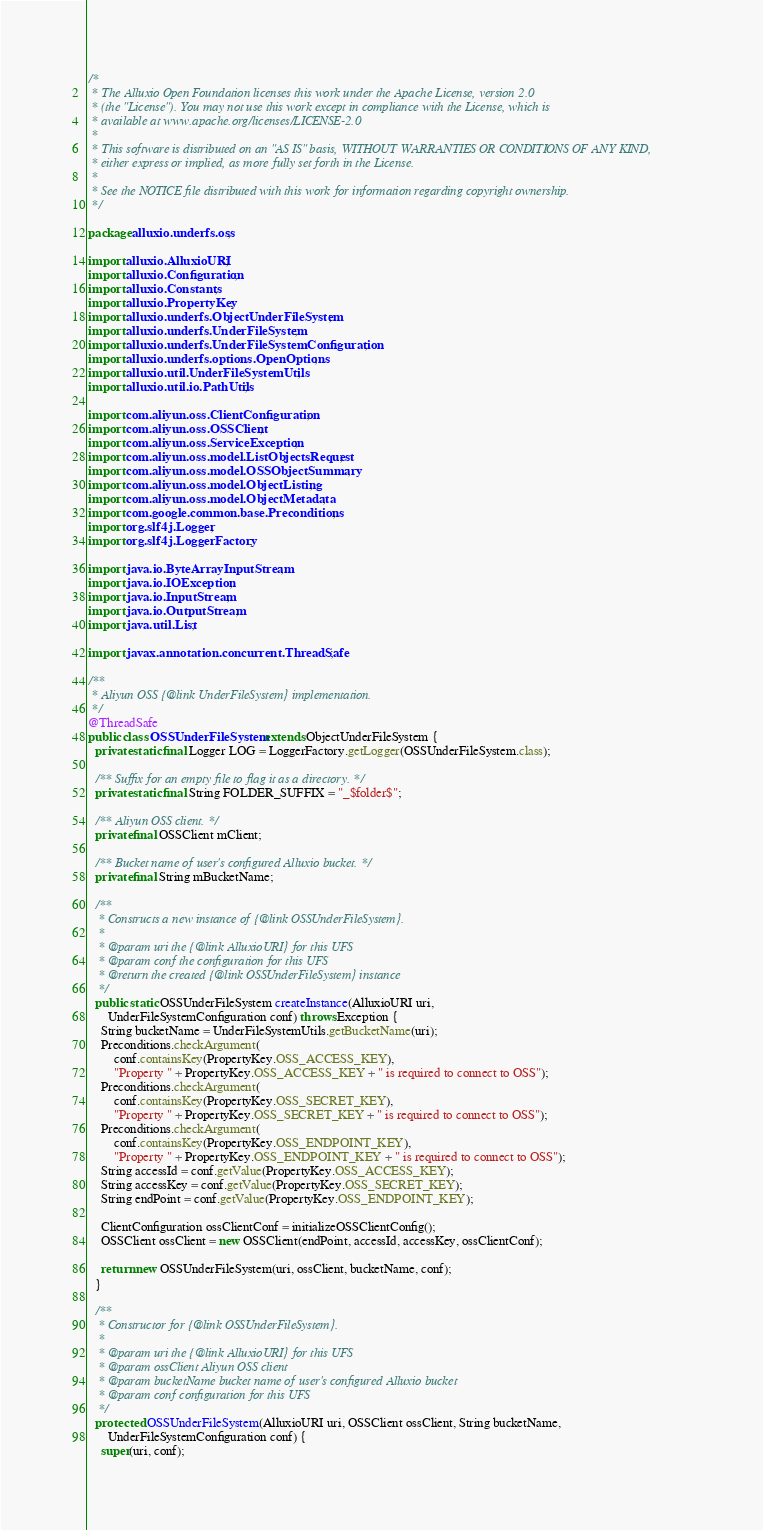<code> <loc_0><loc_0><loc_500><loc_500><_Java_>/*
 * The Alluxio Open Foundation licenses this work under the Apache License, version 2.0
 * (the "License"). You may not use this work except in compliance with the License, which is
 * available at www.apache.org/licenses/LICENSE-2.0
 *
 * This software is distributed on an "AS IS" basis, WITHOUT WARRANTIES OR CONDITIONS OF ANY KIND,
 * either express or implied, as more fully set forth in the License.
 *
 * See the NOTICE file distributed with this work for information regarding copyright ownership.
 */

package alluxio.underfs.oss;

import alluxio.AlluxioURI;
import alluxio.Configuration;
import alluxio.Constants;
import alluxio.PropertyKey;
import alluxio.underfs.ObjectUnderFileSystem;
import alluxio.underfs.UnderFileSystem;
import alluxio.underfs.UnderFileSystemConfiguration;
import alluxio.underfs.options.OpenOptions;
import alluxio.util.UnderFileSystemUtils;
import alluxio.util.io.PathUtils;

import com.aliyun.oss.ClientConfiguration;
import com.aliyun.oss.OSSClient;
import com.aliyun.oss.ServiceException;
import com.aliyun.oss.model.ListObjectsRequest;
import com.aliyun.oss.model.OSSObjectSummary;
import com.aliyun.oss.model.ObjectListing;
import com.aliyun.oss.model.ObjectMetadata;
import com.google.common.base.Preconditions;
import org.slf4j.Logger;
import org.slf4j.LoggerFactory;

import java.io.ByteArrayInputStream;
import java.io.IOException;
import java.io.InputStream;
import java.io.OutputStream;
import java.util.List;

import javax.annotation.concurrent.ThreadSafe;

/**
 * Aliyun OSS {@link UnderFileSystem} implementation.
 */
@ThreadSafe
public class OSSUnderFileSystem extends ObjectUnderFileSystem {
  private static final Logger LOG = LoggerFactory.getLogger(OSSUnderFileSystem.class);

  /** Suffix for an empty file to flag it as a directory. */
  private static final String FOLDER_SUFFIX = "_$folder$";

  /** Aliyun OSS client. */
  private final OSSClient mClient;

  /** Bucket name of user's configured Alluxio bucket. */
  private final String mBucketName;

  /**
   * Constructs a new instance of {@link OSSUnderFileSystem}.
   *
   * @param uri the {@link AlluxioURI} for this UFS
   * @param conf the configuration for this UFS
   * @return the created {@link OSSUnderFileSystem} instance
   */
  public static OSSUnderFileSystem createInstance(AlluxioURI uri,
      UnderFileSystemConfiguration conf) throws Exception {
    String bucketName = UnderFileSystemUtils.getBucketName(uri);
    Preconditions.checkArgument(
        conf.containsKey(PropertyKey.OSS_ACCESS_KEY),
        "Property " + PropertyKey.OSS_ACCESS_KEY + " is required to connect to OSS");
    Preconditions.checkArgument(
        conf.containsKey(PropertyKey.OSS_SECRET_KEY),
        "Property " + PropertyKey.OSS_SECRET_KEY + " is required to connect to OSS");
    Preconditions.checkArgument(
        conf.containsKey(PropertyKey.OSS_ENDPOINT_KEY),
        "Property " + PropertyKey.OSS_ENDPOINT_KEY + " is required to connect to OSS");
    String accessId = conf.getValue(PropertyKey.OSS_ACCESS_KEY);
    String accessKey = conf.getValue(PropertyKey.OSS_SECRET_KEY);
    String endPoint = conf.getValue(PropertyKey.OSS_ENDPOINT_KEY);

    ClientConfiguration ossClientConf = initializeOSSClientConfig();
    OSSClient ossClient = new OSSClient(endPoint, accessId, accessKey, ossClientConf);

    return new OSSUnderFileSystem(uri, ossClient, bucketName, conf);
  }

  /**
   * Constructor for {@link OSSUnderFileSystem}.
   *
   * @param uri the {@link AlluxioURI} for this UFS
   * @param ossClient Aliyun OSS client
   * @param bucketName bucket name of user's configured Alluxio bucket
   * @param conf configuration for this UFS
   */
  protected OSSUnderFileSystem(AlluxioURI uri, OSSClient ossClient, String bucketName,
      UnderFileSystemConfiguration conf) {
    super(uri, conf);</code> 